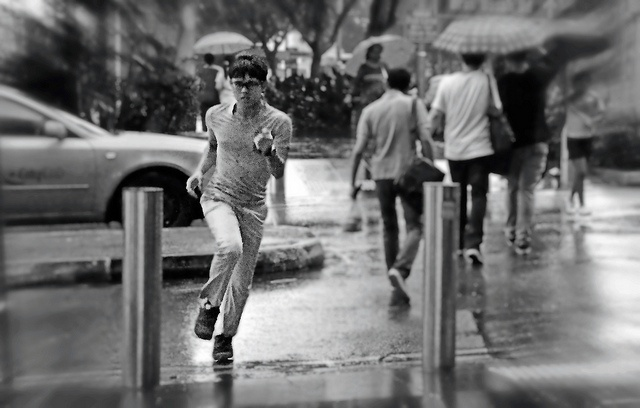Describe the objects in this image and their specific colors. I can see car in lightgray, black, gray, and darkgray tones, people in lightgray, gray, darkgray, and black tones, people in lightgray, black, and gray tones, people in lightgray, gray, black, and darkgray tones, and people in lightgray, darkgray, black, and gray tones in this image. 